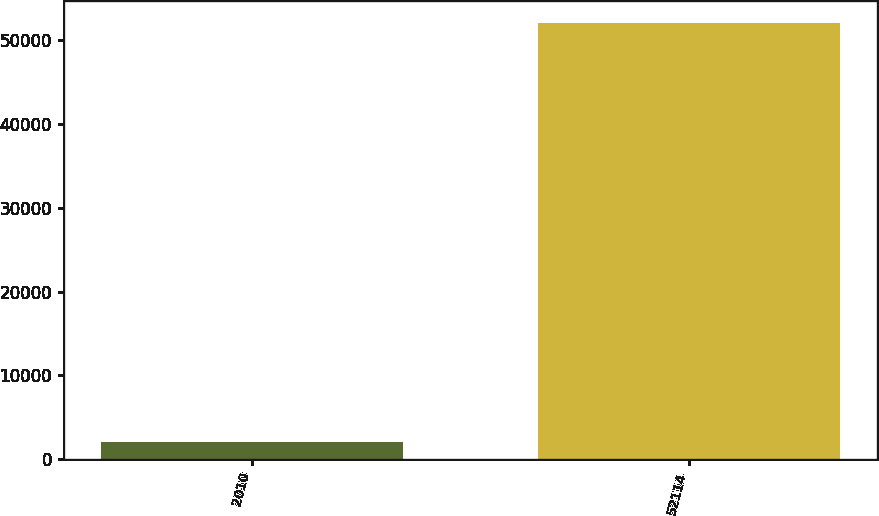<chart> <loc_0><loc_0><loc_500><loc_500><bar_chart><fcel>2010<fcel>52114<nl><fcel>2011<fcel>52087<nl></chart> 